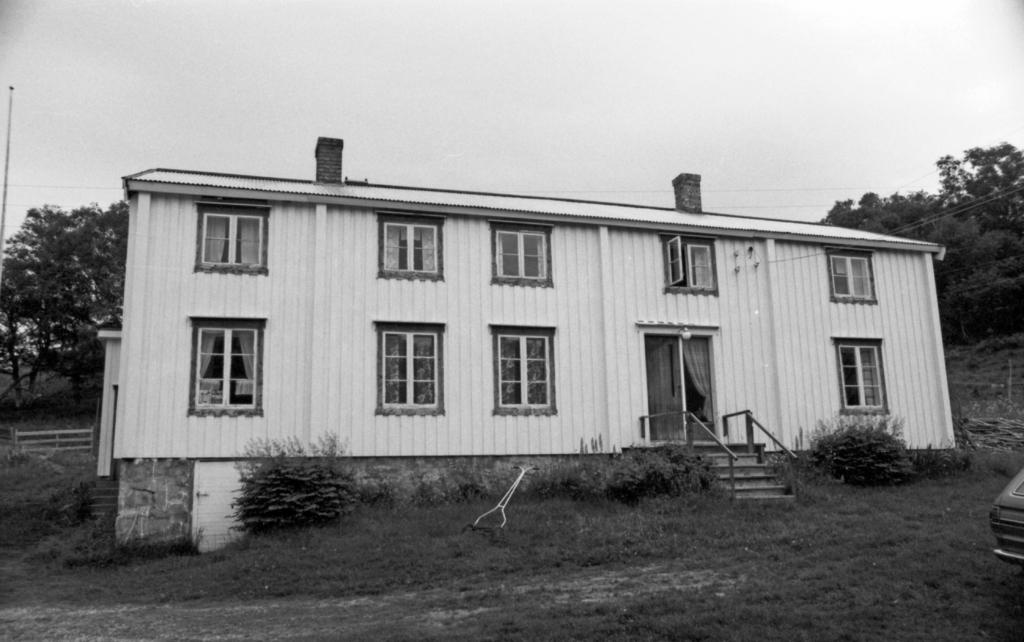What type of building is shown in the image? There is a big building with glass windows in the image. What can be seen in the background of the image? There are many trees in the image. What is the ground made of in the image? There is grass visible at the ground in the image. Can you see any spots on the sidewalk in the image? There is no sidewalk present in the image; it features a big building with glass windows and trees in the background. 